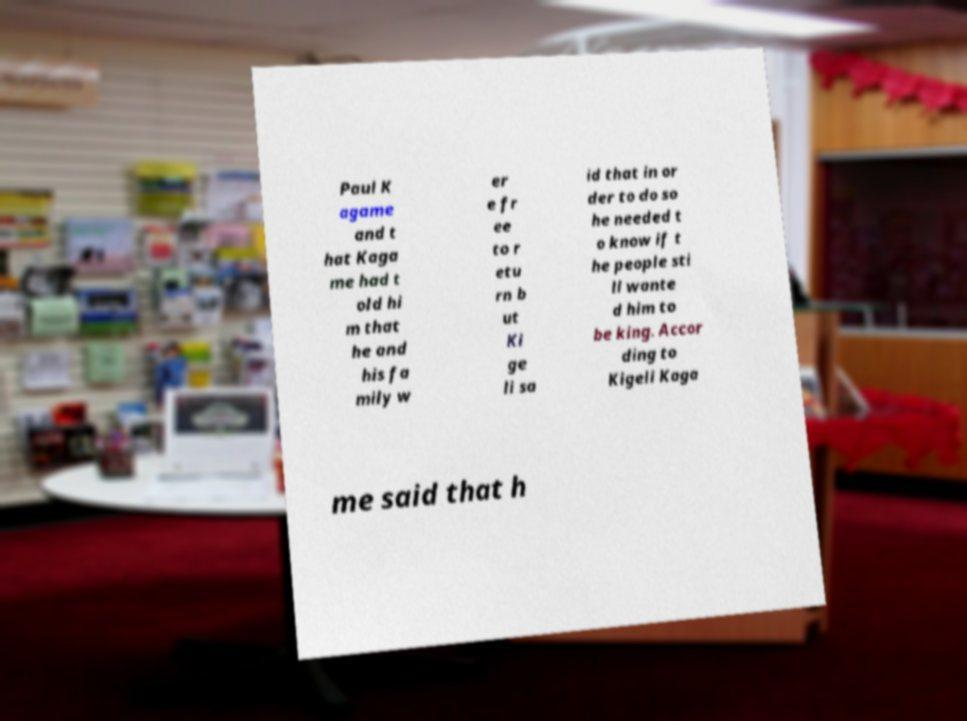Could you extract and type out the text from this image? Paul K agame and t hat Kaga me had t old hi m that he and his fa mily w er e fr ee to r etu rn b ut Ki ge li sa id that in or der to do so he needed t o know if t he people sti ll wante d him to be king. Accor ding to Kigeli Kaga me said that h 